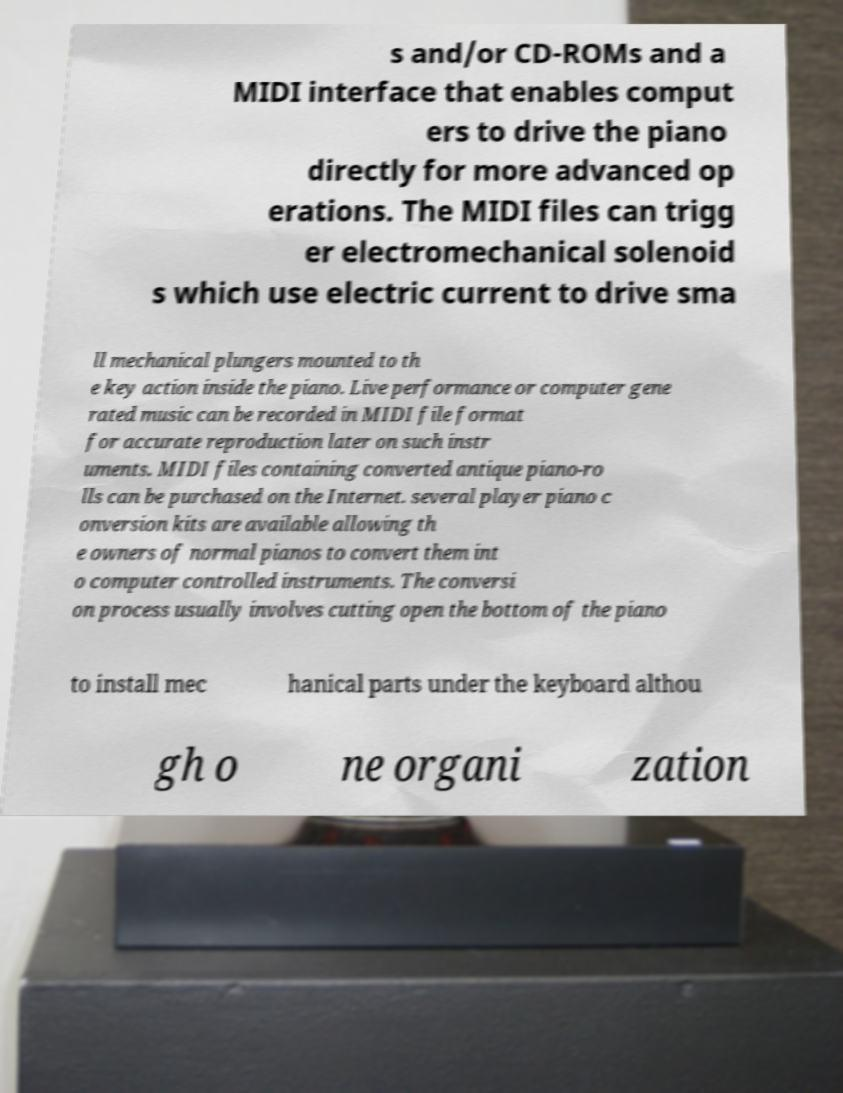For documentation purposes, I need the text within this image transcribed. Could you provide that? s and/or CD-ROMs and a MIDI interface that enables comput ers to drive the piano directly for more advanced op erations. The MIDI files can trigg er electromechanical solenoid s which use electric current to drive sma ll mechanical plungers mounted to th e key action inside the piano. Live performance or computer gene rated music can be recorded in MIDI file format for accurate reproduction later on such instr uments. MIDI files containing converted antique piano-ro lls can be purchased on the Internet. several player piano c onversion kits are available allowing th e owners of normal pianos to convert them int o computer controlled instruments. The conversi on process usually involves cutting open the bottom of the piano to install mec hanical parts under the keyboard althou gh o ne organi zation 